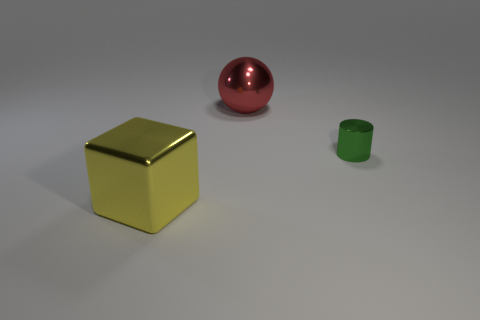Add 3 large metallic cylinders. How many objects exist? 6 Subtract all cylinders. How many objects are left? 2 Subtract all blocks. Subtract all tiny cylinders. How many objects are left? 1 Add 3 yellow cubes. How many yellow cubes are left? 4 Add 2 shiny cylinders. How many shiny cylinders exist? 3 Subtract 0 blue balls. How many objects are left? 3 